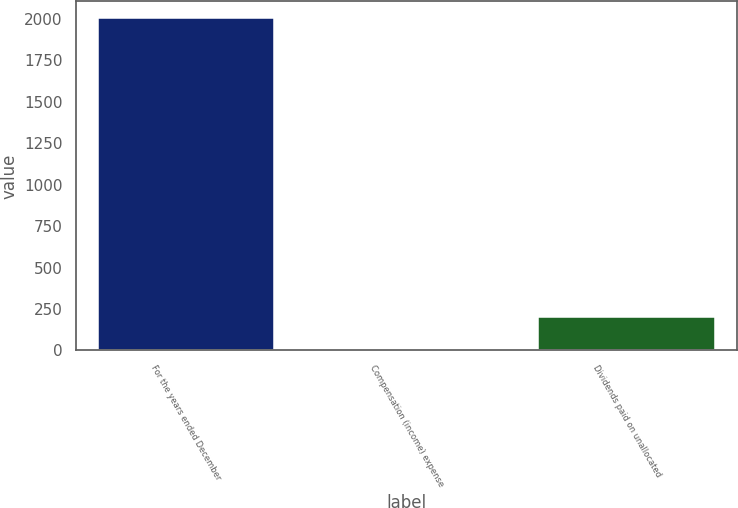Convert chart. <chart><loc_0><loc_0><loc_500><loc_500><bar_chart><fcel>For the years ended December<fcel>Compensation (income) expense<fcel>Dividends paid on unallocated<nl><fcel>2004<fcel>0.1<fcel>200.49<nl></chart> 